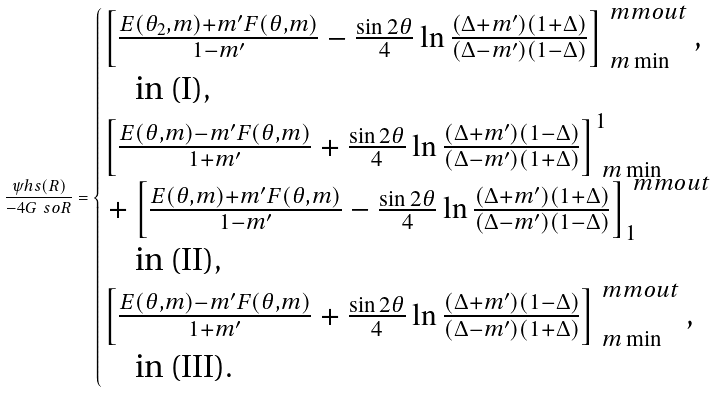Convert formula to latex. <formula><loc_0><loc_0><loc_500><loc_500>\frac { \psi h s ( R ) } { - 4 G \ s o R } = \begin{cases} \left [ \frac { E ( \theta _ { 2 } , m ) + m ^ { \prime } F ( \theta , m ) } { 1 - m ^ { \prime } } - \frac { \sin 2 \theta } { 4 } \ln \frac { ( \Delta + m ^ { \prime } ) ( 1 + \Delta ) } { ( \Delta - m ^ { \prime } ) ( 1 - \Delta ) } \right ] _ { \ m \min } ^ { \ m m o u t } , \\ \quad \text {in (I)} , \\ \left [ \frac { E ( \theta , m ) - m ^ { \prime } F ( \theta , m ) } { 1 + m ^ { \prime } } + \frac { \sin 2 \theta } { 4 } \ln \frac { ( \Delta + m ^ { \prime } ) ( 1 - \Delta ) } { ( \Delta - m ^ { \prime } ) ( 1 + \Delta ) } \right ] _ { \ m \min } ^ { 1 } \\ \, + \left [ \frac { E ( \theta , m ) + m ^ { \prime } F ( \theta , m ) } { 1 - m ^ { \prime } } - \frac { \sin 2 \theta } { 4 } \ln \frac { ( \Delta + m ^ { \prime } ) ( 1 + \Delta ) } { ( \Delta - m ^ { \prime } ) ( 1 - \Delta ) } \right ] _ { 1 } ^ { \ m m o u t } \\ \quad \text {in (II)} , \\ \left [ \frac { E ( \theta , m ) - m ^ { \prime } F ( \theta , m ) } { 1 + m ^ { \prime } } + \frac { \sin 2 \theta } { 4 } \ln \frac { ( \Delta + m ^ { \prime } ) ( 1 - \Delta ) } { ( \Delta - m ^ { \prime } ) ( 1 + \Delta ) } \right ] _ { \ m \min } ^ { \ m m o u t } , \\ \quad \text {in (III)} . \end{cases}</formula> 